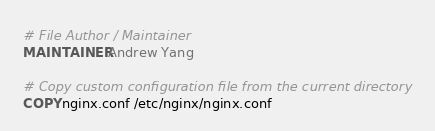Convert code to text. <code><loc_0><loc_0><loc_500><loc_500><_Dockerfile_># File Author / Maintainer
MAINTAINER Andrew Yang

# Copy custom configuration file from the current directory
COPY nginx.conf /etc/nginx/nginx.conf
</code> 